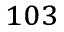<formula> <loc_0><loc_0><loc_500><loc_500>^ { 1 0 3 }</formula> 